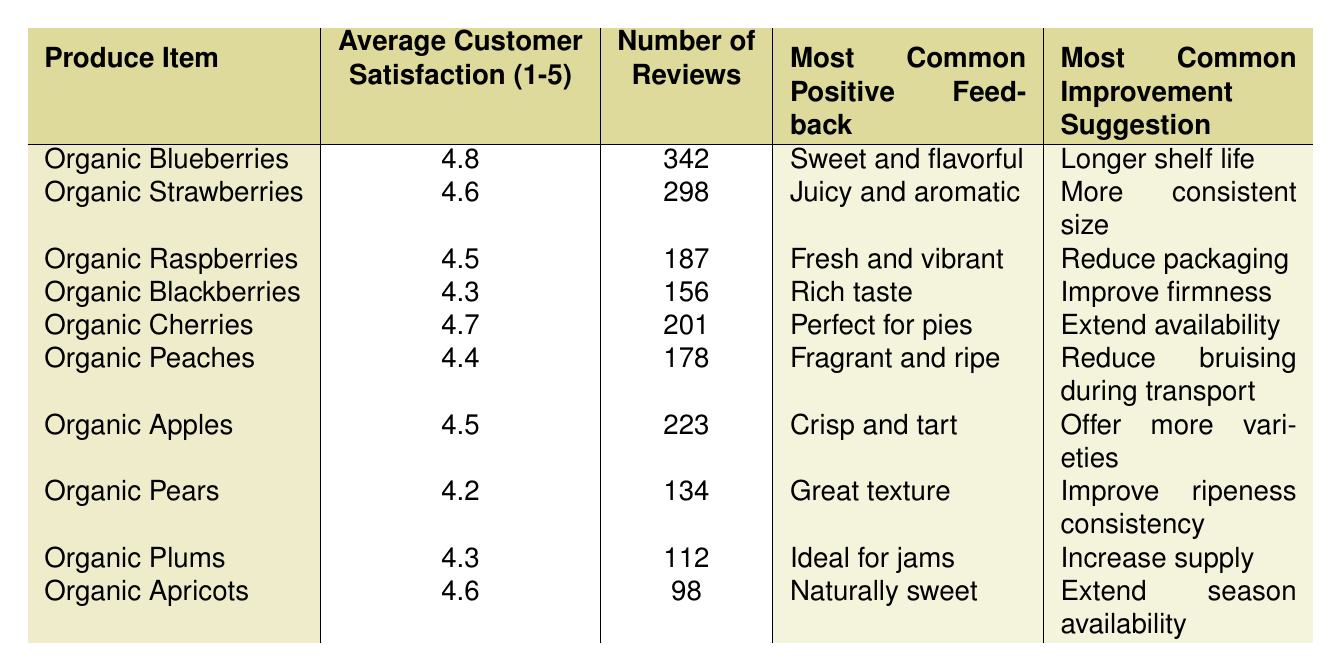What is the average customer satisfaction rating for Organic Blueberries? The table shows that the average customer satisfaction rating for Organic Blueberries is listed as 4.8.
Answer: 4.8 How many reviews were provided for Organic Strawberries? The table indicates that Organic Strawberries received a total of 298 reviews.
Answer: 298 Which produce item has the highest average customer satisfaction rating? By comparing the average customer satisfaction ratings in the table, Organic Blueberries have the highest rating at 4.8.
Answer: Organic Blueberries What is the most common positive feedback for Organic Cherries? The table states that the most common positive feedback for Organic Cherries is "Perfect for pies."
Answer: Perfect for pies Do Organic Pears have a lower average customer satisfaction than Organic Raspberries? A comparison of the average ratings shows that Organic Pears have a rating of 4.2 while Organic Raspberries have a rating of 4.5, hence Pears do have a lower rating.
Answer: Yes Calculate the difference in the number of reviews between Organic Blackberries and Organic Cherries. Organic Blackberries have 156 reviews and Organic Cherries have 201 reviews. The difference is 201 - 156 = 45.
Answer: 45 Is the most common improvement suggestion for Organic Apricots to extend their season availability? According to the table, the most common improvement suggestion for Organic Apricots is indeed to "Extend season availability," confirming the statement is true.
Answer: Yes Which produce item has both the lowest average customer satisfaction and the fewest reviews? Organic Pears have the lowest average customer satisfaction of 4.2 and also have the fewest reviews at 134, making it the answer to the question.
Answer: Organic Pears What is the average customer satisfaction rating for all produce items listed in the table? To find the average, sum the average ratings: (4.8 + 4.6 + 4.5 + 4.3 + 4.7 + 4.4 + 4.5 + 4.2 + 4.3 + 4.6) = 44.9. There are 10 items, so the average is 44.9 / 10 = 4.49.
Answer: 4.49 Which produce item has the most reviews and what is the average satisfaction rating for that item? The table shows that Organic Blueberries have the highest number of reviews at 342, with an average satisfaction rating of 4.8.
Answer: Organic Blueberries, 4.8 